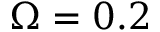Convert formula to latex. <formula><loc_0><loc_0><loc_500><loc_500>\Omega = 0 . 2</formula> 